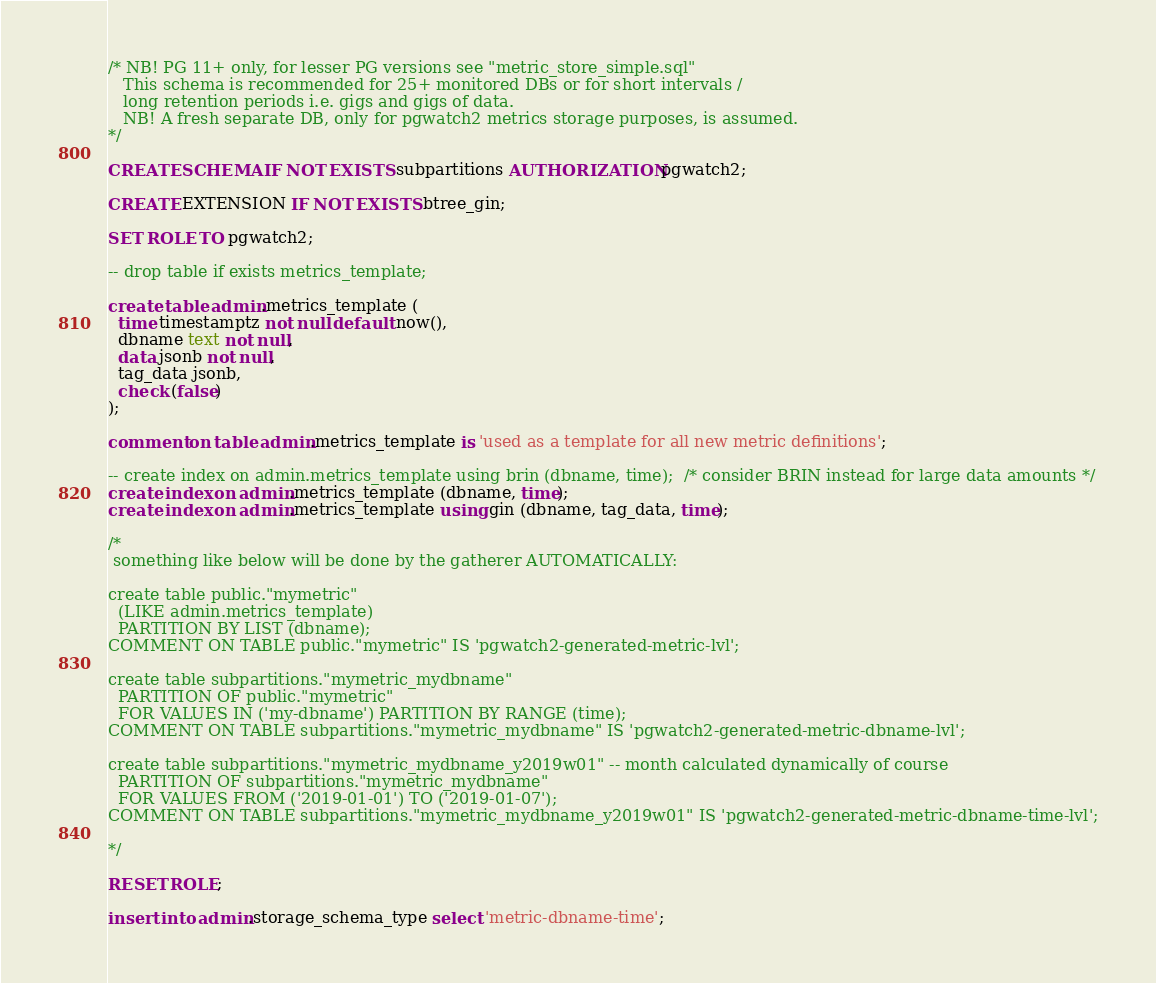<code> <loc_0><loc_0><loc_500><loc_500><_SQL_>/* NB! PG 11+ only, for lesser PG versions see "metric_store_simple.sql"
   This schema is recommended for 25+ monitored DBs or for short intervals /
   long retention periods i.e. gigs and gigs of data.
   NB! A fresh separate DB, only for pgwatch2 metrics storage purposes, is assumed.
*/

CREATE SCHEMA IF NOT EXISTS subpartitions AUTHORIZATION pgwatch2;

CREATE EXTENSION IF NOT EXISTS btree_gin;

SET ROLE TO pgwatch2;

-- drop table if exists metrics_template;

create table admin.metrics_template (
  time timestamptz not null default now(),
  dbname text not null,
  data jsonb not null,
  tag_data jsonb,
  check (false)
);

comment on table admin.metrics_template is 'used as a template for all new metric definitions';

-- create index on admin.metrics_template using brin (dbname, time);  /* consider BRIN instead for large data amounts */
create index on admin.metrics_template (dbname, time);
create index on admin.metrics_template using gin (dbname, tag_data, time);

/*
 something like below will be done by the gatherer AUTOMATICALLY:

create table public."mymetric"
  (LIKE admin.metrics_template)
  PARTITION BY LIST (dbname);
COMMENT ON TABLE public."mymetric" IS 'pgwatch2-generated-metric-lvl';

create table subpartitions."mymetric_mydbname"
  PARTITION OF public."mymetric"
  FOR VALUES IN ('my-dbname') PARTITION BY RANGE (time);
COMMENT ON TABLE subpartitions."mymetric_mydbname" IS 'pgwatch2-generated-metric-dbname-lvl';

create table subpartitions."mymetric_mydbname_y2019w01" -- month calculated dynamically of course
  PARTITION OF subpartitions."mymetric_mydbname"
  FOR VALUES FROM ('2019-01-01') TO ('2019-01-07');
COMMENT ON TABLE subpartitions."mymetric_mydbname_y2019w01" IS 'pgwatch2-generated-metric-dbname-time-lvl';

*/

RESET ROLE;

insert into admin.storage_schema_type select 'metric-dbname-time';
</code> 